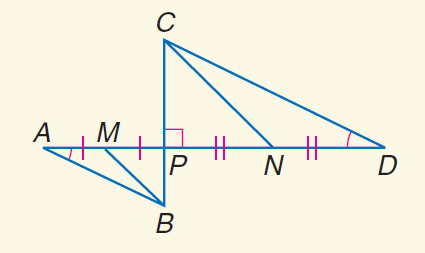Question: Find the perimeter of \triangle C P D if the perimeter of \triangle B P A is 12, B M = \sqrt { 13 }, and C N = 3 \sqrt { 13 }.
Choices:
A. 6
B. 12
C. 24
D. 36
Answer with the letter. Answer: D 